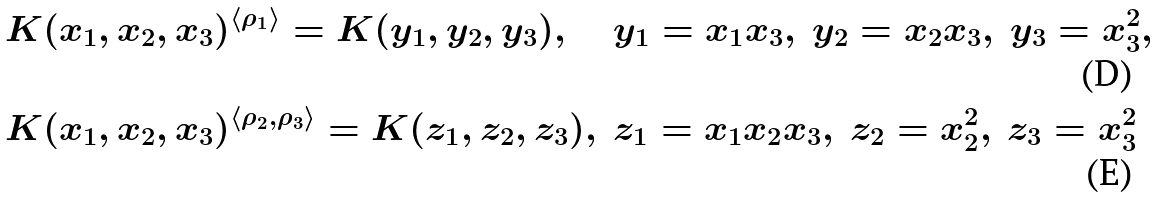Convert formula to latex. <formula><loc_0><loc_0><loc_500><loc_500>& K ( x _ { 1 } , x _ { 2 } , x _ { 3 } ) ^ { \langle \rho _ { 1 } \rangle } = K ( y _ { 1 } , y _ { 2 } , y _ { 3 } ) , & & y _ { 1 } = x _ { 1 } x _ { 3 } , \ y _ { 2 } = x _ { 2 } x _ { 3 } , \ y _ { 3 } = x _ { 3 } ^ { 2 } , \\ & K ( x _ { 1 } , x _ { 2 } , x _ { 3 } ) ^ { \langle \rho _ { 2 } , \rho _ { 3 } \rangle } = K ( z _ { 1 } , z _ { 2 } , z _ { 3 } ) , & & z _ { 1 } = x _ { 1 } x _ { 2 } x _ { 3 } , \ z _ { 2 } = x _ { 2 } ^ { 2 } , \ z _ { 3 } = x _ { 3 } ^ { 2 }</formula> 